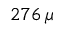Convert formula to latex. <formula><loc_0><loc_0><loc_500><loc_500>2 7 6 \, \mu</formula> 